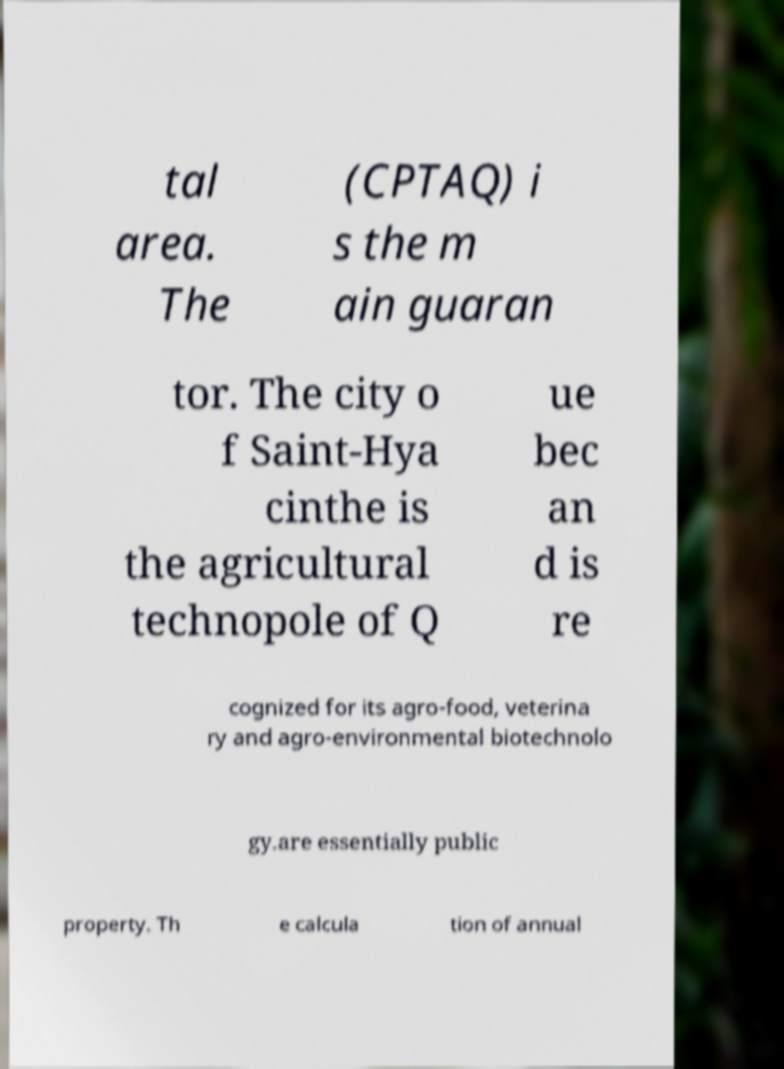Please identify and transcribe the text found in this image. tal area. The (CPTAQ) i s the m ain guaran tor. The city o f Saint-Hya cinthe is the agricultural technopole of Q ue bec an d is re cognized for its agro-food, veterina ry and agro-environmental biotechnolo gy.are essentially public property. Th e calcula tion of annual 